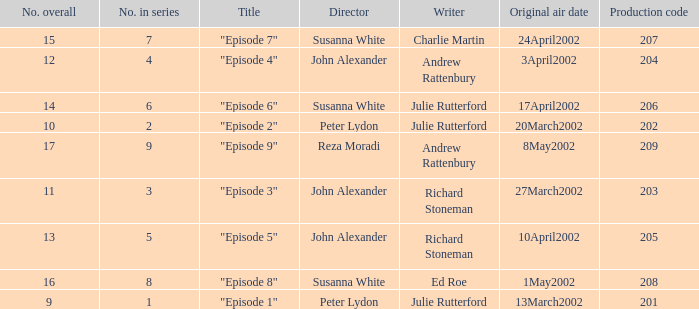When "episode 1" is the title what is the overall number? 9.0. 